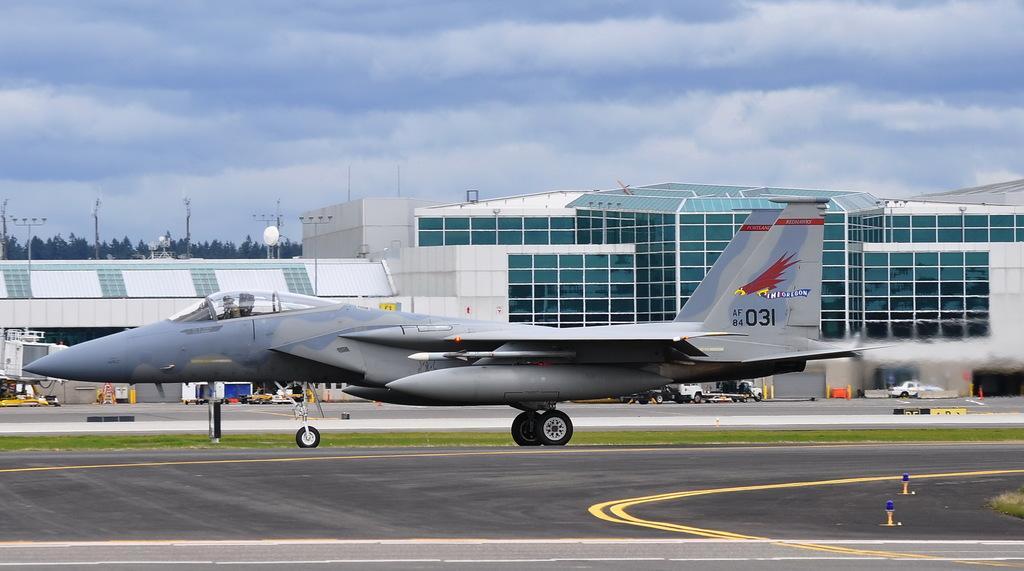How would you summarize this image in a sentence or two? There is an airport and in front of the airport there is a flight parked on the land and behind the flight there are many trucks and other vehicles. Behind them there is a compartment and in the background there are many trees and poles. 